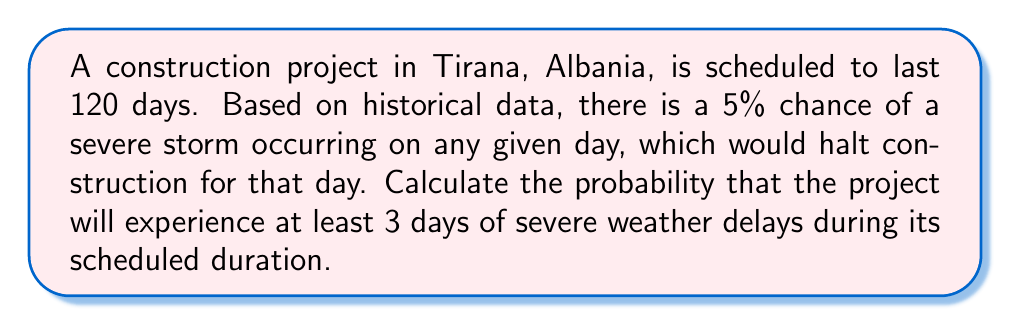Solve this math problem. Let's approach this step-by-step:

1) This scenario follows a binomial probability distribution, where:
   - $n = 120$ (number of days)
   - $p = 0.05$ (probability of a severe storm on any day)
   - We want to find $P(X \geq 3)$, where $X$ is the number of severe storm days

2) The probability of at least 3 days of severe weather is the complement of the probability of 0, 1, or 2 days of severe weather:

   $P(X \geq 3) = 1 - [P(X = 0) + P(X = 1) + P(X = 2)]$

3) We can calculate each probability using the binomial probability formula:

   $P(X = k) = \binom{n}{k} p^k (1-p)^{n-k}$

4) Let's calculate each term:

   $P(X = 0) = \binom{120}{0} (0.05)^0 (0.95)^{120} = 0.0022$

   $P(X = 1) = \binom{120}{1} (0.05)^1 (0.95)^{119} = 0.0140$

   $P(X = 2) = \binom{120}{2} (0.05)^2 (0.95)^{118} = 0.0432$

5) Now, we can sum these probabilities and subtract from 1:

   $P(X \geq 3) = 1 - (0.0022 + 0.0140 + 0.0432) = 1 - 0.0594 = 0.9406$

6) Therefore, the probability of experiencing at least 3 days of severe weather delays is approximately 0.9406 or 94.06%.
Answer: 0.9406 